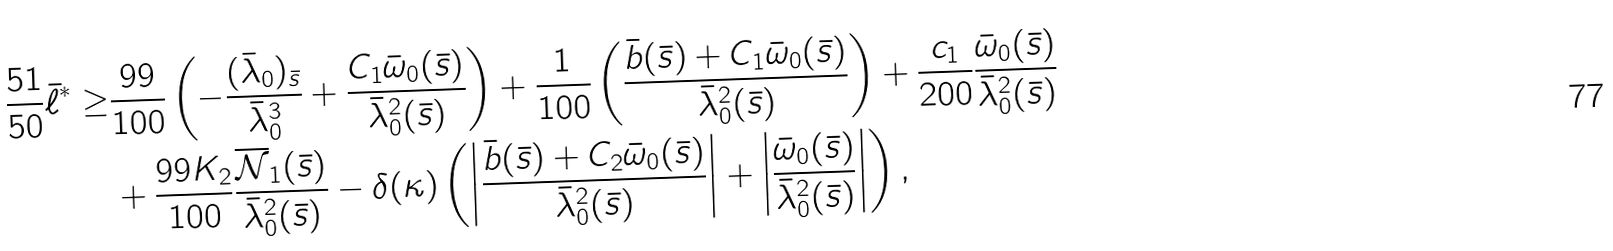Convert formula to latex. <formula><loc_0><loc_0><loc_500><loc_500>\frac { 5 1 } { 5 0 } \bar { \ell } ^ { * } \geq & \frac { 9 9 } { 1 0 0 } \left ( - \frac { ( \bar { \lambda } _ { 0 } ) _ { \bar { s } } } { \bar { \lambda } ^ { 3 } _ { 0 } } + \frac { C _ { 1 } \bar { \omega } _ { 0 } ( \bar { s } ) } { \bar { \lambda } _ { 0 } ^ { 2 } ( \bar { s } ) } \right ) + \frac { 1 } { 1 0 0 } \left ( \frac { \bar { b } ( \bar { s } ) + C _ { 1 } \bar { \omega } _ { 0 } ( \bar { s } ) } { \bar { \lambda } _ { 0 } ^ { 2 } ( \bar { s } ) } \right ) + \frac { c _ { 1 } } { 2 0 0 } \frac { \bar { \omega } _ { 0 } ( \bar { s } ) } { \bar { \lambda } _ { 0 } ^ { 2 } ( \bar { s } ) } \\ & + \frac { 9 9 K _ { 2 } } { 1 0 0 } \frac { \overline { \mathcal { N } } _ { 1 } ( \bar { s } ) } { \bar { \lambda } _ { 0 } ^ { 2 } ( \bar { s } ) } - \delta ( \kappa ) \left ( \left | \frac { \bar { b } ( \bar { s } ) + C _ { 2 } \bar { \omega } _ { 0 } ( \bar { s } ) } { \bar { \lambda } _ { 0 } ^ { 2 } ( \bar { s } ) } \right | + \left | \frac { \bar { \omega } _ { 0 } ( \bar { s } ) } { \bar { \lambda } _ { 0 } ^ { 2 } ( \bar { s } ) } \right | \right ) , \\</formula> 